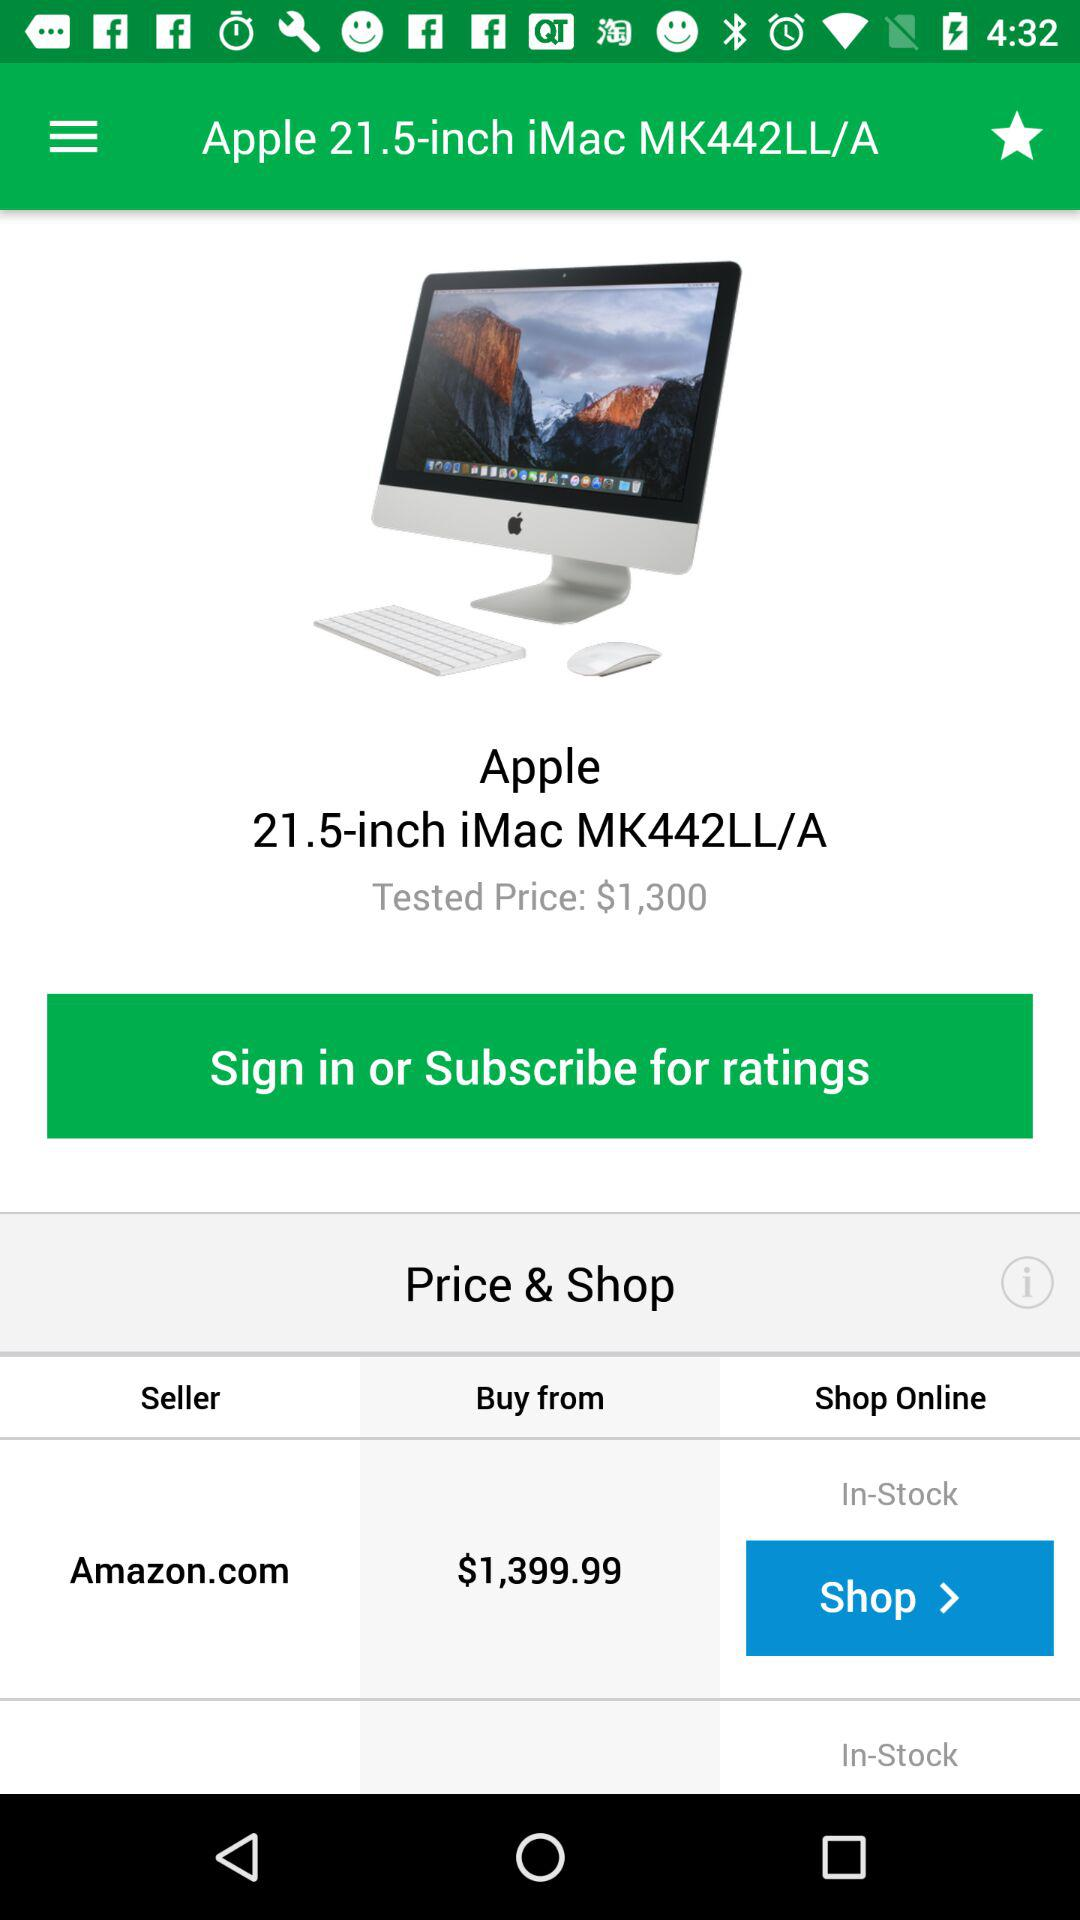How much more does the Apple product cost than the Amazon product?
Answer the question using a single word or phrase. $99.99 